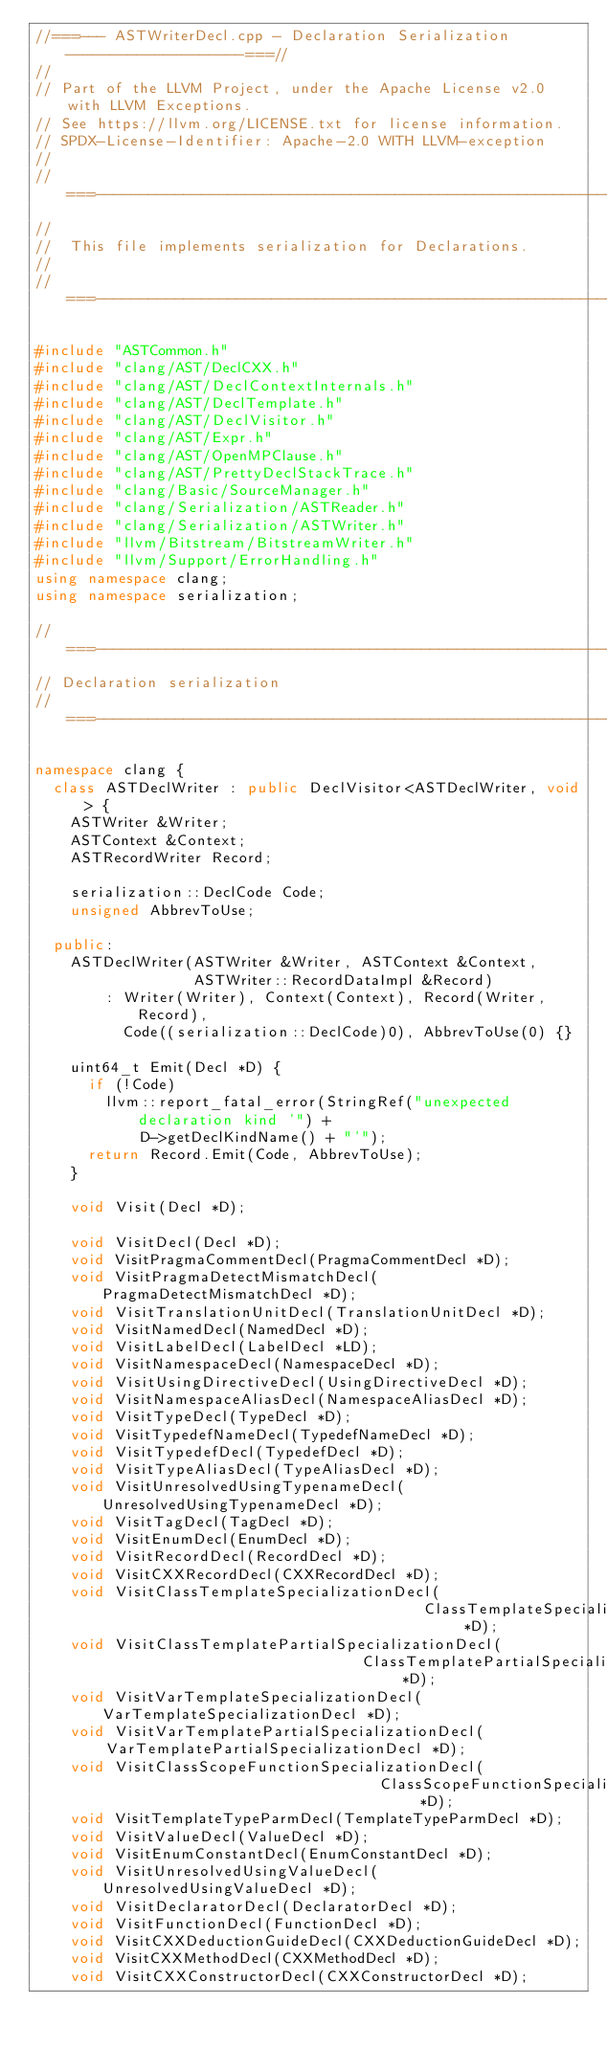Convert code to text. <code><loc_0><loc_0><loc_500><loc_500><_C++_>//===--- ASTWriterDecl.cpp - Declaration Serialization --------------------===//
//
// Part of the LLVM Project, under the Apache License v2.0 with LLVM Exceptions.
// See https://llvm.org/LICENSE.txt for license information.
// SPDX-License-Identifier: Apache-2.0 WITH LLVM-exception
//
//===----------------------------------------------------------------------===//
//
//  This file implements serialization for Declarations.
//
//===----------------------------------------------------------------------===//

#include "ASTCommon.h"
#include "clang/AST/DeclCXX.h"
#include "clang/AST/DeclContextInternals.h"
#include "clang/AST/DeclTemplate.h"
#include "clang/AST/DeclVisitor.h"
#include "clang/AST/Expr.h"
#include "clang/AST/OpenMPClause.h"
#include "clang/AST/PrettyDeclStackTrace.h"
#include "clang/Basic/SourceManager.h"
#include "clang/Serialization/ASTReader.h"
#include "clang/Serialization/ASTWriter.h"
#include "llvm/Bitstream/BitstreamWriter.h"
#include "llvm/Support/ErrorHandling.h"
using namespace clang;
using namespace serialization;

//===----------------------------------------------------------------------===//
// Declaration serialization
//===----------------------------------------------------------------------===//

namespace clang {
  class ASTDeclWriter : public DeclVisitor<ASTDeclWriter, void> {
    ASTWriter &Writer;
    ASTContext &Context;
    ASTRecordWriter Record;

    serialization::DeclCode Code;
    unsigned AbbrevToUse;

  public:
    ASTDeclWriter(ASTWriter &Writer, ASTContext &Context,
                  ASTWriter::RecordDataImpl &Record)
        : Writer(Writer), Context(Context), Record(Writer, Record),
          Code((serialization::DeclCode)0), AbbrevToUse(0) {}

    uint64_t Emit(Decl *D) {
      if (!Code)
        llvm::report_fatal_error(StringRef("unexpected declaration kind '") +
            D->getDeclKindName() + "'");
      return Record.Emit(Code, AbbrevToUse);
    }

    void Visit(Decl *D);

    void VisitDecl(Decl *D);
    void VisitPragmaCommentDecl(PragmaCommentDecl *D);
    void VisitPragmaDetectMismatchDecl(PragmaDetectMismatchDecl *D);
    void VisitTranslationUnitDecl(TranslationUnitDecl *D);
    void VisitNamedDecl(NamedDecl *D);
    void VisitLabelDecl(LabelDecl *LD);
    void VisitNamespaceDecl(NamespaceDecl *D);
    void VisitUsingDirectiveDecl(UsingDirectiveDecl *D);
    void VisitNamespaceAliasDecl(NamespaceAliasDecl *D);
    void VisitTypeDecl(TypeDecl *D);
    void VisitTypedefNameDecl(TypedefNameDecl *D);
    void VisitTypedefDecl(TypedefDecl *D);
    void VisitTypeAliasDecl(TypeAliasDecl *D);
    void VisitUnresolvedUsingTypenameDecl(UnresolvedUsingTypenameDecl *D);
    void VisitTagDecl(TagDecl *D);
    void VisitEnumDecl(EnumDecl *D);
    void VisitRecordDecl(RecordDecl *D);
    void VisitCXXRecordDecl(CXXRecordDecl *D);
    void VisitClassTemplateSpecializationDecl(
                                            ClassTemplateSpecializationDecl *D);
    void VisitClassTemplatePartialSpecializationDecl(
                                     ClassTemplatePartialSpecializationDecl *D);
    void VisitVarTemplateSpecializationDecl(VarTemplateSpecializationDecl *D);
    void VisitVarTemplatePartialSpecializationDecl(
        VarTemplatePartialSpecializationDecl *D);
    void VisitClassScopeFunctionSpecializationDecl(
                                       ClassScopeFunctionSpecializationDecl *D);
    void VisitTemplateTypeParmDecl(TemplateTypeParmDecl *D);
    void VisitValueDecl(ValueDecl *D);
    void VisitEnumConstantDecl(EnumConstantDecl *D);
    void VisitUnresolvedUsingValueDecl(UnresolvedUsingValueDecl *D);
    void VisitDeclaratorDecl(DeclaratorDecl *D);
    void VisitFunctionDecl(FunctionDecl *D);
    void VisitCXXDeductionGuideDecl(CXXDeductionGuideDecl *D);
    void VisitCXXMethodDecl(CXXMethodDecl *D);
    void VisitCXXConstructorDecl(CXXConstructorDecl *D);</code> 